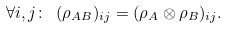<formula> <loc_0><loc_0><loc_500><loc_500>\forall i , j \colon \ ( \rho _ { A B } ) _ { i j } = ( \rho _ { A } \otimes \rho _ { B } ) _ { i j } .</formula> 